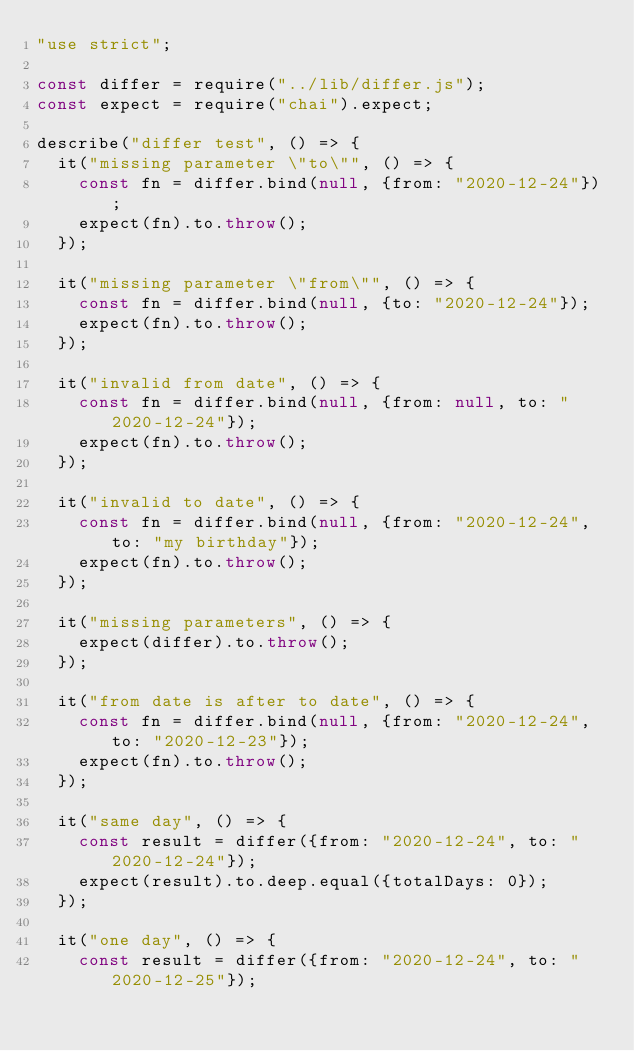<code> <loc_0><loc_0><loc_500><loc_500><_JavaScript_>"use strict";

const differ = require("../lib/differ.js");
const expect = require("chai").expect;

describe("differ test", () => {
  it("missing parameter \"to\"", () => {
    const fn = differ.bind(null, {from: "2020-12-24"});
    expect(fn).to.throw();
  });

  it("missing parameter \"from\"", () => {
    const fn = differ.bind(null, {to: "2020-12-24"});
    expect(fn).to.throw();
  });

  it("invalid from date", () => {
    const fn = differ.bind(null, {from: null, to: "2020-12-24"});
    expect(fn).to.throw();
  });

  it("invalid to date", () => {
    const fn = differ.bind(null, {from: "2020-12-24", to: "my birthday"});
    expect(fn).to.throw();
  });

  it("missing parameters", () => {
    expect(differ).to.throw();
  });

  it("from date is after to date", () => {
    const fn = differ.bind(null, {from: "2020-12-24", to: "2020-12-23"});
    expect(fn).to.throw();
  });

  it("same day", () => {
    const result = differ({from: "2020-12-24", to: "2020-12-24"});
    expect(result).to.deep.equal({totalDays: 0});
  });

  it("one day", () => {
    const result = differ({from: "2020-12-24", to: "2020-12-25"});</code> 